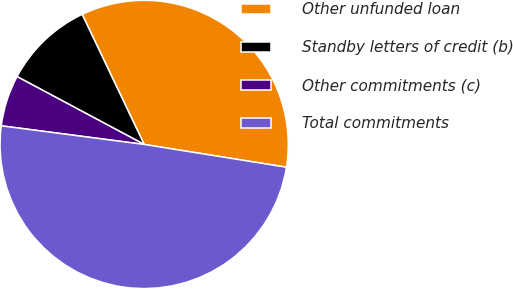<chart> <loc_0><loc_0><loc_500><loc_500><pie_chart><fcel>Other unfunded loan<fcel>Standby letters of credit (b)<fcel>Other commitments (c)<fcel>Total commitments<nl><fcel>34.61%<fcel>10.12%<fcel>5.74%<fcel>49.54%<nl></chart> 